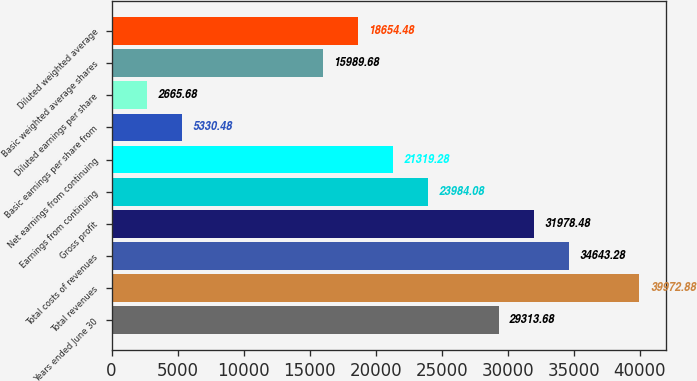Convert chart to OTSL. <chart><loc_0><loc_0><loc_500><loc_500><bar_chart><fcel>Years ended June 30<fcel>Total revenues<fcel>Total costs of revenues<fcel>Gross profit<fcel>Earnings from continuing<fcel>Net earnings from continuing<fcel>Basic earnings per share from<fcel>Diluted earnings per share<fcel>Basic weighted average shares<fcel>Diluted weighted average<nl><fcel>29313.7<fcel>39972.9<fcel>34643.3<fcel>31978.5<fcel>23984.1<fcel>21319.3<fcel>5330.48<fcel>2665.68<fcel>15989.7<fcel>18654.5<nl></chart> 